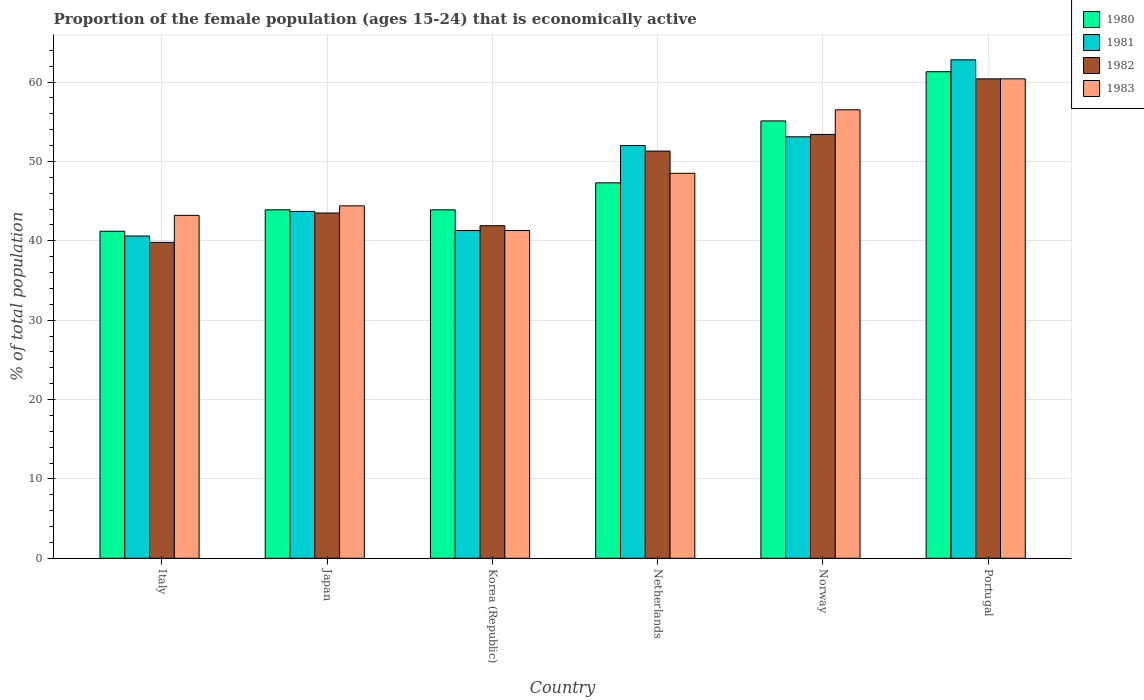How many bars are there on the 4th tick from the right?
Your answer should be very brief. 4. In how many cases, is the number of bars for a given country not equal to the number of legend labels?
Give a very brief answer. 0. What is the proportion of the female population that is economically active in 1981 in Italy?
Provide a succinct answer. 40.6. Across all countries, what is the maximum proportion of the female population that is economically active in 1982?
Your answer should be compact. 60.4. Across all countries, what is the minimum proportion of the female population that is economically active in 1983?
Offer a terse response. 41.3. In which country was the proportion of the female population that is economically active in 1980 maximum?
Ensure brevity in your answer.  Portugal. In which country was the proportion of the female population that is economically active in 1982 minimum?
Ensure brevity in your answer.  Italy. What is the total proportion of the female population that is economically active in 1982 in the graph?
Your response must be concise. 290.3. What is the difference between the proportion of the female population that is economically active in 1980 in Italy and the proportion of the female population that is economically active in 1982 in Norway?
Your answer should be very brief. -12.2. What is the average proportion of the female population that is economically active in 1980 per country?
Provide a succinct answer. 48.78. What is the difference between the proportion of the female population that is economically active of/in 1983 and proportion of the female population that is economically active of/in 1981 in Portugal?
Offer a terse response. -2.4. What is the ratio of the proportion of the female population that is economically active in 1981 in Korea (Republic) to that in Netherlands?
Offer a very short reply. 0.79. What is the difference between the highest and the second highest proportion of the female population that is economically active in 1982?
Your response must be concise. -9.1. What is the difference between the highest and the lowest proportion of the female population that is economically active in 1981?
Give a very brief answer. 22.2. In how many countries, is the proportion of the female population that is economically active in 1983 greater than the average proportion of the female population that is economically active in 1983 taken over all countries?
Offer a terse response. 2. Is the sum of the proportion of the female population that is economically active in 1981 in Korea (Republic) and Netherlands greater than the maximum proportion of the female population that is economically active in 1983 across all countries?
Provide a short and direct response. Yes. How many countries are there in the graph?
Keep it short and to the point. 6. What is the difference between two consecutive major ticks on the Y-axis?
Ensure brevity in your answer.  10. How many legend labels are there?
Provide a short and direct response. 4. How are the legend labels stacked?
Ensure brevity in your answer.  Vertical. What is the title of the graph?
Offer a terse response. Proportion of the female population (ages 15-24) that is economically active. What is the label or title of the Y-axis?
Your answer should be very brief. % of total population. What is the % of total population of 1980 in Italy?
Your response must be concise. 41.2. What is the % of total population of 1981 in Italy?
Your answer should be compact. 40.6. What is the % of total population of 1982 in Italy?
Your answer should be very brief. 39.8. What is the % of total population in 1983 in Italy?
Give a very brief answer. 43.2. What is the % of total population of 1980 in Japan?
Offer a very short reply. 43.9. What is the % of total population of 1981 in Japan?
Ensure brevity in your answer.  43.7. What is the % of total population of 1982 in Japan?
Offer a very short reply. 43.5. What is the % of total population of 1983 in Japan?
Your answer should be very brief. 44.4. What is the % of total population in 1980 in Korea (Republic)?
Provide a short and direct response. 43.9. What is the % of total population of 1981 in Korea (Republic)?
Offer a terse response. 41.3. What is the % of total population in 1982 in Korea (Republic)?
Your response must be concise. 41.9. What is the % of total population of 1983 in Korea (Republic)?
Offer a very short reply. 41.3. What is the % of total population in 1980 in Netherlands?
Make the answer very short. 47.3. What is the % of total population in 1981 in Netherlands?
Offer a terse response. 52. What is the % of total population in 1982 in Netherlands?
Give a very brief answer. 51.3. What is the % of total population in 1983 in Netherlands?
Provide a succinct answer. 48.5. What is the % of total population in 1980 in Norway?
Give a very brief answer. 55.1. What is the % of total population in 1981 in Norway?
Offer a terse response. 53.1. What is the % of total population in 1982 in Norway?
Offer a terse response. 53.4. What is the % of total population in 1983 in Norway?
Offer a terse response. 56.5. What is the % of total population in 1980 in Portugal?
Your answer should be compact. 61.3. What is the % of total population of 1981 in Portugal?
Offer a very short reply. 62.8. What is the % of total population of 1982 in Portugal?
Give a very brief answer. 60.4. What is the % of total population in 1983 in Portugal?
Offer a terse response. 60.4. Across all countries, what is the maximum % of total population of 1980?
Offer a terse response. 61.3. Across all countries, what is the maximum % of total population in 1981?
Offer a very short reply. 62.8. Across all countries, what is the maximum % of total population of 1982?
Give a very brief answer. 60.4. Across all countries, what is the maximum % of total population of 1983?
Your response must be concise. 60.4. Across all countries, what is the minimum % of total population in 1980?
Your answer should be very brief. 41.2. Across all countries, what is the minimum % of total population in 1981?
Keep it short and to the point. 40.6. Across all countries, what is the minimum % of total population of 1982?
Your response must be concise. 39.8. Across all countries, what is the minimum % of total population of 1983?
Provide a succinct answer. 41.3. What is the total % of total population in 1980 in the graph?
Provide a succinct answer. 292.7. What is the total % of total population of 1981 in the graph?
Ensure brevity in your answer.  293.5. What is the total % of total population in 1982 in the graph?
Your answer should be very brief. 290.3. What is the total % of total population of 1983 in the graph?
Your response must be concise. 294.3. What is the difference between the % of total population of 1980 in Italy and that in Japan?
Ensure brevity in your answer.  -2.7. What is the difference between the % of total population in 1983 in Italy and that in Japan?
Ensure brevity in your answer.  -1.2. What is the difference between the % of total population of 1982 in Italy and that in Korea (Republic)?
Your answer should be very brief. -2.1. What is the difference between the % of total population in 1983 in Italy and that in Korea (Republic)?
Ensure brevity in your answer.  1.9. What is the difference between the % of total population of 1982 in Italy and that in Netherlands?
Offer a terse response. -11.5. What is the difference between the % of total population of 1981 in Italy and that in Norway?
Keep it short and to the point. -12.5. What is the difference between the % of total population in 1982 in Italy and that in Norway?
Offer a terse response. -13.6. What is the difference between the % of total population in 1983 in Italy and that in Norway?
Ensure brevity in your answer.  -13.3. What is the difference between the % of total population of 1980 in Italy and that in Portugal?
Ensure brevity in your answer.  -20.1. What is the difference between the % of total population of 1981 in Italy and that in Portugal?
Offer a terse response. -22.2. What is the difference between the % of total population of 1982 in Italy and that in Portugal?
Make the answer very short. -20.6. What is the difference between the % of total population in 1983 in Italy and that in Portugal?
Provide a short and direct response. -17.2. What is the difference between the % of total population of 1980 in Japan and that in Korea (Republic)?
Your answer should be very brief. 0. What is the difference between the % of total population of 1982 in Japan and that in Korea (Republic)?
Give a very brief answer. 1.6. What is the difference between the % of total population in 1983 in Japan and that in Korea (Republic)?
Provide a short and direct response. 3.1. What is the difference between the % of total population of 1981 in Japan and that in Netherlands?
Ensure brevity in your answer.  -8.3. What is the difference between the % of total population in 1982 in Japan and that in Netherlands?
Your response must be concise. -7.8. What is the difference between the % of total population of 1983 in Japan and that in Netherlands?
Your response must be concise. -4.1. What is the difference between the % of total population of 1980 in Japan and that in Norway?
Provide a short and direct response. -11.2. What is the difference between the % of total population in 1980 in Japan and that in Portugal?
Provide a succinct answer. -17.4. What is the difference between the % of total population in 1981 in Japan and that in Portugal?
Give a very brief answer. -19.1. What is the difference between the % of total population in 1982 in Japan and that in Portugal?
Keep it short and to the point. -16.9. What is the difference between the % of total population of 1983 in Japan and that in Portugal?
Provide a short and direct response. -16. What is the difference between the % of total population in 1982 in Korea (Republic) and that in Netherlands?
Keep it short and to the point. -9.4. What is the difference between the % of total population of 1983 in Korea (Republic) and that in Netherlands?
Offer a very short reply. -7.2. What is the difference between the % of total population in 1980 in Korea (Republic) and that in Norway?
Your answer should be compact. -11.2. What is the difference between the % of total population of 1982 in Korea (Republic) and that in Norway?
Give a very brief answer. -11.5. What is the difference between the % of total population in 1983 in Korea (Republic) and that in Norway?
Ensure brevity in your answer.  -15.2. What is the difference between the % of total population in 1980 in Korea (Republic) and that in Portugal?
Provide a succinct answer. -17.4. What is the difference between the % of total population of 1981 in Korea (Republic) and that in Portugal?
Your response must be concise. -21.5. What is the difference between the % of total population of 1982 in Korea (Republic) and that in Portugal?
Give a very brief answer. -18.5. What is the difference between the % of total population of 1983 in Korea (Republic) and that in Portugal?
Your answer should be compact. -19.1. What is the difference between the % of total population of 1981 in Netherlands and that in Norway?
Offer a very short reply. -1.1. What is the difference between the % of total population in 1982 in Netherlands and that in Portugal?
Provide a short and direct response. -9.1. What is the difference between the % of total population of 1980 in Norway and that in Portugal?
Provide a short and direct response. -6.2. What is the difference between the % of total population of 1981 in Norway and that in Portugal?
Your answer should be compact. -9.7. What is the difference between the % of total population of 1982 in Norway and that in Portugal?
Ensure brevity in your answer.  -7. What is the difference between the % of total population of 1983 in Norway and that in Portugal?
Your response must be concise. -3.9. What is the difference between the % of total population in 1980 in Italy and the % of total population in 1981 in Japan?
Give a very brief answer. -2.5. What is the difference between the % of total population in 1981 in Italy and the % of total population in 1983 in Japan?
Your answer should be compact. -3.8. What is the difference between the % of total population in 1982 in Italy and the % of total population in 1983 in Japan?
Keep it short and to the point. -4.6. What is the difference between the % of total population of 1980 in Italy and the % of total population of 1982 in Korea (Republic)?
Offer a very short reply. -0.7. What is the difference between the % of total population in 1980 in Italy and the % of total population in 1983 in Korea (Republic)?
Ensure brevity in your answer.  -0.1. What is the difference between the % of total population of 1981 in Italy and the % of total population of 1983 in Korea (Republic)?
Ensure brevity in your answer.  -0.7. What is the difference between the % of total population in 1980 in Italy and the % of total population in 1981 in Netherlands?
Provide a short and direct response. -10.8. What is the difference between the % of total population of 1980 in Italy and the % of total population of 1983 in Netherlands?
Offer a terse response. -7.3. What is the difference between the % of total population in 1980 in Italy and the % of total population in 1982 in Norway?
Give a very brief answer. -12.2. What is the difference between the % of total population in 1980 in Italy and the % of total population in 1983 in Norway?
Give a very brief answer. -15.3. What is the difference between the % of total population of 1981 in Italy and the % of total population of 1983 in Norway?
Your answer should be compact. -15.9. What is the difference between the % of total population of 1982 in Italy and the % of total population of 1983 in Norway?
Your answer should be compact. -16.7. What is the difference between the % of total population of 1980 in Italy and the % of total population of 1981 in Portugal?
Your answer should be compact. -21.6. What is the difference between the % of total population of 1980 in Italy and the % of total population of 1982 in Portugal?
Your answer should be very brief. -19.2. What is the difference between the % of total population of 1980 in Italy and the % of total population of 1983 in Portugal?
Make the answer very short. -19.2. What is the difference between the % of total population in 1981 in Italy and the % of total population in 1982 in Portugal?
Your response must be concise. -19.8. What is the difference between the % of total population of 1981 in Italy and the % of total population of 1983 in Portugal?
Keep it short and to the point. -19.8. What is the difference between the % of total population in 1982 in Italy and the % of total population in 1983 in Portugal?
Give a very brief answer. -20.6. What is the difference between the % of total population of 1980 in Japan and the % of total population of 1983 in Korea (Republic)?
Offer a terse response. 2.6. What is the difference between the % of total population of 1981 in Japan and the % of total population of 1983 in Korea (Republic)?
Offer a very short reply. 2.4. What is the difference between the % of total population of 1982 in Japan and the % of total population of 1983 in Korea (Republic)?
Offer a terse response. 2.2. What is the difference between the % of total population of 1980 in Japan and the % of total population of 1981 in Netherlands?
Offer a very short reply. -8.1. What is the difference between the % of total population in 1980 in Japan and the % of total population in 1983 in Netherlands?
Give a very brief answer. -4.6. What is the difference between the % of total population in 1981 in Japan and the % of total population in 1983 in Netherlands?
Provide a short and direct response. -4.8. What is the difference between the % of total population of 1982 in Japan and the % of total population of 1983 in Netherlands?
Provide a short and direct response. -5. What is the difference between the % of total population in 1980 in Japan and the % of total population in 1983 in Norway?
Your answer should be compact. -12.6. What is the difference between the % of total population in 1981 in Japan and the % of total population in 1982 in Norway?
Provide a succinct answer. -9.7. What is the difference between the % of total population in 1980 in Japan and the % of total population in 1981 in Portugal?
Offer a terse response. -18.9. What is the difference between the % of total population in 1980 in Japan and the % of total population in 1982 in Portugal?
Your answer should be very brief. -16.5. What is the difference between the % of total population in 1980 in Japan and the % of total population in 1983 in Portugal?
Provide a short and direct response. -16.5. What is the difference between the % of total population in 1981 in Japan and the % of total population in 1982 in Portugal?
Offer a terse response. -16.7. What is the difference between the % of total population in 1981 in Japan and the % of total population in 1983 in Portugal?
Make the answer very short. -16.7. What is the difference between the % of total population of 1982 in Japan and the % of total population of 1983 in Portugal?
Your response must be concise. -16.9. What is the difference between the % of total population of 1980 in Korea (Republic) and the % of total population of 1982 in Netherlands?
Keep it short and to the point. -7.4. What is the difference between the % of total population of 1980 in Korea (Republic) and the % of total population of 1983 in Netherlands?
Keep it short and to the point. -4.6. What is the difference between the % of total population in 1981 in Korea (Republic) and the % of total population in 1982 in Netherlands?
Give a very brief answer. -10. What is the difference between the % of total population of 1980 in Korea (Republic) and the % of total population of 1982 in Norway?
Keep it short and to the point. -9.5. What is the difference between the % of total population of 1980 in Korea (Republic) and the % of total population of 1983 in Norway?
Provide a short and direct response. -12.6. What is the difference between the % of total population of 1981 in Korea (Republic) and the % of total population of 1982 in Norway?
Offer a terse response. -12.1. What is the difference between the % of total population of 1981 in Korea (Republic) and the % of total population of 1983 in Norway?
Your answer should be very brief. -15.2. What is the difference between the % of total population in 1982 in Korea (Republic) and the % of total population in 1983 in Norway?
Your response must be concise. -14.6. What is the difference between the % of total population of 1980 in Korea (Republic) and the % of total population of 1981 in Portugal?
Keep it short and to the point. -18.9. What is the difference between the % of total population in 1980 in Korea (Republic) and the % of total population in 1982 in Portugal?
Provide a succinct answer. -16.5. What is the difference between the % of total population of 1980 in Korea (Republic) and the % of total population of 1983 in Portugal?
Ensure brevity in your answer.  -16.5. What is the difference between the % of total population of 1981 in Korea (Republic) and the % of total population of 1982 in Portugal?
Provide a short and direct response. -19.1. What is the difference between the % of total population of 1981 in Korea (Republic) and the % of total population of 1983 in Portugal?
Provide a short and direct response. -19.1. What is the difference between the % of total population in 1982 in Korea (Republic) and the % of total population in 1983 in Portugal?
Offer a terse response. -18.5. What is the difference between the % of total population in 1980 in Netherlands and the % of total population in 1983 in Norway?
Provide a succinct answer. -9.2. What is the difference between the % of total population in 1981 in Netherlands and the % of total population in 1982 in Norway?
Give a very brief answer. -1.4. What is the difference between the % of total population of 1981 in Netherlands and the % of total population of 1983 in Norway?
Make the answer very short. -4.5. What is the difference between the % of total population in 1980 in Netherlands and the % of total population in 1981 in Portugal?
Give a very brief answer. -15.5. What is the difference between the % of total population in 1980 in Netherlands and the % of total population in 1983 in Portugal?
Ensure brevity in your answer.  -13.1. What is the difference between the % of total population of 1981 in Netherlands and the % of total population of 1983 in Portugal?
Ensure brevity in your answer.  -8.4. What is the difference between the % of total population in 1980 in Norway and the % of total population in 1981 in Portugal?
Provide a short and direct response. -7.7. What is the difference between the % of total population of 1980 in Norway and the % of total population of 1983 in Portugal?
Ensure brevity in your answer.  -5.3. What is the difference between the % of total population in 1981 in Norway and the % of total population in 1982 in Portugal?
Your answer should be compact. -7.3. What is the difference between the % of total population of 1982 in Norway and the % of total population of 1983 in Portugal?
Keep it short and to the point. -7. What is the average % of total population of 1980 per country?
Your answer should be compact. 48.78. What is the average % of total population of 1981 per country?
Offer a terse response. 48.92. What is the average % of total population of 1982 per country?
Offer a terse response. 48.38. What is the average % of total population of 1983 per country?
Your response must be concise. 49.05. What is the difference between the % of total population of 1980 and % of total population of 1982 in Italy?
Your answer should be compact. 1.4. What is the difference between the % of total population in 1982 and % of total population in 1983 in Italy?
Make the answer very short. -3.4. What is the difference between the % of total population of 1980 and % of total population of 1981 in Japan?
Your answer should be very brief. 0.2. What is the difference between the % of total population in 1980 and % of total population in 1982 in Japan?
Your answer should be compact. 0.4. What is the difference between the % of total population of 1980 and % of total population of 1983 in Japan?
Offer a very short reply. -0.5. What is the difference between the % of total population of 1982 and % of total population of 1983 in Japan?
Offer a very short reply. -0.9. What is the difference between the % of total population in 1980 and % of total population in 1981 in Korea (Republic)?
Your answer should be very brief. 2.6. What is the difference between the % of total population in 1980 and % of total population in 1983 in Korea (Republic)?
Ensure brevity in your answer.  2.6. What is the difference between the % of total population of 1981 and % of total population of 1983 in Korea (Republic)?
Ensure brevity in your answer.  0. What is the difference between the % of total population in 1982 and % of total population in 1983 in Korea (Republic)?
Keep it short and to the point. 0.6. What is the difference between the % of total population of 1980 and % of total population of 1981 in Netherlands?
Offer a terse response. -4.7. What is the difference between the % of total population of 1980 and % of total population of 1983 in Netherlands?
Make the answer very short. -1.2. What is the difference between the % of total population in 1981 and % of total population in 1982 in Netherlands?
Give a very brief answer. 0.7. What is the difference between the % of total population of 1982 and % of total population of 1983 in Netherlands?
Give a very brief answer. 2.8. What is the difference between the % of total population in 1980 and % of total population in 1982 in Norway?
Provide a short and direct response. 1.7. What is the difference between the % of total population in 1980 and % of total population in 1983 in Norway?
Ensure brevity in your answer.  -1.4. What is the difference between the % of total population of 1980 and % of total population of 1982 in Portugal?
Keep it short and to the point. 0.9. What is the difference between the % of total population of 1981 and % of total population of 1983 in Portugal?
Offer a very short reply. 2.4. What is the ratio of the % of total population of 1980 in Italy to that in Japan?
Make the answer very short. 0.94. What is the ratio of the % of total population in 1981 in Italy to that in Japan?
Your answer should be compact. 0.93. What is the ratio of the % of total population of 1982 in Italy to that in Japan?
Give a very brief answer. 0.91. What is the ratio of the % of total population in 1983 in Italy to that in Japan?
Ensure brevity in your answer.  0.97. What is the ratio of the % of total population in 1980 in Italy to that in Korea (Republic)?
Offer a terse response. 0.94. What is the ratio of the % of total population of 1981 in Italy to that in Korea (Republic)?
Keep it short and to the point. 0.98. What is the ratio of the % of total population in 1982 in Italy to that in Korea (Republic)?
Your answer should be compact. 0.95. What is the ratio of the % of total population in 1983 in Italy to that in Korea (Republic)?
Keep it short and to the point. 1.05. What is the ratio of the % of total population in 1980 in Italy to that in Netherlands?
Your response must be concise. 0.87. What is the ratio of the % of total population of 1981 in Italy to that in Netherlands?
Provide a succinct answer. 0.78. What is the ratio of the % of total population of 1982 in Italy to that in Netherlands?
Your response must be concise. 0.78. What is the ratio of the % of total population of 1983 in Italy to that in Netherlands?
Give a very brief answer. 0.89. What is the ratio of the % of total population of 1980 in Italy to that in Norway?
Provide a short and direct response. 0.75. What is the ratio of the % of total population of 1981 in Italy to that in Norway?
Ensure brevity in your answer.  0.76. What is the ratio of the % of total population in 1982 in Italy to that in Norway?
Your response must be concise. 0.75. What is the ratio of the % of total population of 1983 in Italy to that in Norway?
Your answer should be very brief. 0.76. What is the ratio of the % of total population in 1980 in Italy to that in Portugal?
Provide a short and direct response. 0.67. What is the ratio of the % of total population of 1981 in Italy to that in Portugal?
Your answer should be very brief. 0.65. What is the ratio of the % of total population in 1982 in Italy to that in Portugal?
Offer a terse response. 0.66. What is the ratio of the % of total population in 1983 in Italy to that in Portugal?
Provide a succinct answer. 0.72. What is the ratio of the % of total population in 1980 in Japan to that in Korea (Republic)?
Your answer should be very brief. 1. What is the ratio of the % of total population of 1981 in Japan to that in Korea (Republic)?
Your answer should be very brief. 1.06. What is the ratio of the % of total population of 1982 in Japan to that in Korea (Republic)?
Give a very brief answer. 1.04. What is the ratio of the % of total population in 1983 in Japan to that in Korea (Republic)?
Keep it short and to the point. 1.08. What is the ratio of the % of total population of 1980 in Japan to that in Netherlands?
Ensure brevity in your answer.  0.93. What is the ratio of the % of total population in 1981 in Japan to that in Netherlands?
Ensure brevity in your answer.  0.84. What is the ratio of the % of total population of 1982 in Japan to that in Netherlands?
Your answer should be very brief. 0.85. What is the ratio of the % of total population in 1983 in Japan to that in Netherlands?
Ensure brevity in your answer.  0.92. What is the ratio of the % of total population of 1980 in Japan to that in Norway?
Provide a succinct answer. 0.8. What is the ratio of the % of total population in 1981 in Japan to that in Norway?
Offer a very short reply. 0.82. What is the ratio of the % of total population in 1982 in Japan to that in Norway?
Make the answer very short. 0.81. What is the ratio of the % of total population in 1983 in Japan to that in Norway?
Make the answer very short. 0.79. What is the ratio of the % of total population of 1980 in Japan to that in Portugal?
Make the answer very short. 0.72. What is the ratio of the % of total population of 1981 in Japan to that in Portugal?
Your answer should be very brief. 0.7. What is the ratio of the % of total population in 1982 in Japan to that in Portugal?
Keep it short and to the point. 0.72. What is the ratio of the % of total population in 1983 in Japan to that in Portugal?
Keep it short and to the point. 0.74. What is the ratio of the % of total population in 1980 in Korea (Republic) to that in Netherlands?
Provide a succinct answer. 0.93. What is the ratio of the % of total population of 1981 in Korea (Republic) to that in Netherlands?
Give a very brief answer. 0.79. What is the ratio of the % of total population of 1982 in Korea (Republic) to that in Netherlands?
Provide a succinct answer. 0.82. What is the ratio of the % of total population in 1983 in Korea (Republic) to that in Netherlands?
Make the answer very short. 0.85. What is the ratio of the % of total population in 1980 in Korea (Republic) to that in Norway?
Offer a terse response. 0.8. What is the ratio of the % of total population in 1982 in Korea (Republic) to that in Norway?
Offer a very short reply. 0.78. What is the ratio of the % of total population of 1983 in Korea (Republic) to that in Norway?
Provide a short and direct response. 0.73. What is the ratio of the % of total population in 1980 in Korea (Republic) to that in Portugal?
Your response must be concise. 0.72. What is the ratio of the % of total population of 1981 in Korea (Republic) to that in Portugal?
Provide a succinct answer. 0.66. What is the ratio of the % of total population in 1982 in Korea (Republic) to that in Portugal?
Keep it short and to the point. 0.69. What is the ratio of the % of total population of 1983 in Korea (Republic) to that in Portugal?
Give a very brief answer. 0.68. What is the ratio of the % of total population of 1980 in Netherlands to that in Norway?
Ensure brevity in your answer.  0.86. What is the ratio of the % of total population in 1981 in Netherlands to that in Norway?
Give a very brief answer. 0.98. What is the ratio of the % of total population in 1982 in Netherlands to that in Norway?
Offer a very short reply. 0.96. What is the ratio of the % of total population of 1983 in Netherlands to that in Norway?
Keep it short and to the point. 0.86. What is the ratio of the % of total population of 1980 in Netherlands to that in Portugal?
Your answer should be compact. 0.77. What is the ratio of the % of total population in 1981 in Netherlands to that in Portugal?
Make the answer very short. 0.83. What is the ratio of the % of total population in 1982 in Netherlands to that in Portugal?
Ensure brevity in your answer.  0.85. What is the ratio of the % of total population of 1983 in Netherlands to that in Portugal?
Make the answer very short. 0.8. What is the ratio of the % of total population of 1980 in Norway to that in Portugal?
Offer a terse response. 0.9. What is the ratio of the % of total population in 1981 in Norway to that in Portugal?
Give a very brief answer. 0.85. What is the ratio of the % of total population in 1982 in Norway to that in Portugal?
Ensure brevity in your answer.  0.88. What is the ratio of the % of total population in 1983 in Norway to that in Portugal?
Provide a succinct answer. 0.94. What is the difference between the highest and the second highest % of total population of 1980?
Ensure brevity in your answer.  6.2. What is the difference between the highest and the second highest % of total population of 1983?
Provide a succinct answer. 3.9. What is the difference between the highest and the lowest % of total population of 1980?
Your answer should be very brief. 20.1. What is the difference between the highest and the lowest % of total population of 1981?
Provide a succinct answer. 22.2. What is the difference between the highest and the lowest % of total population of 1982?
Keep it short and to the point. 20.6. 